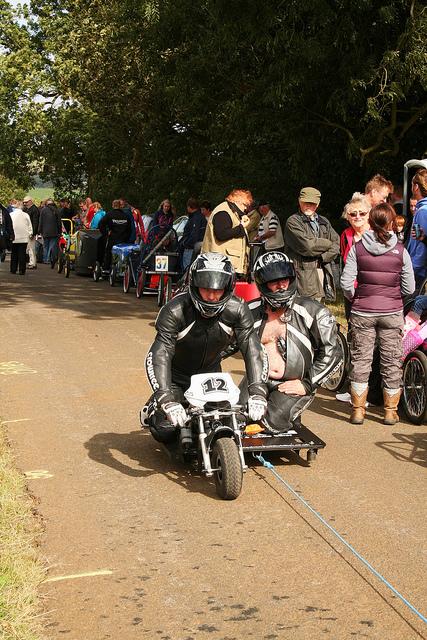How many men are riding the motorcycle?
Answer briefly. 2. What color are the women's boots?
Be succinct. Brown. What color is the grass?
Answer briefly. Green. 